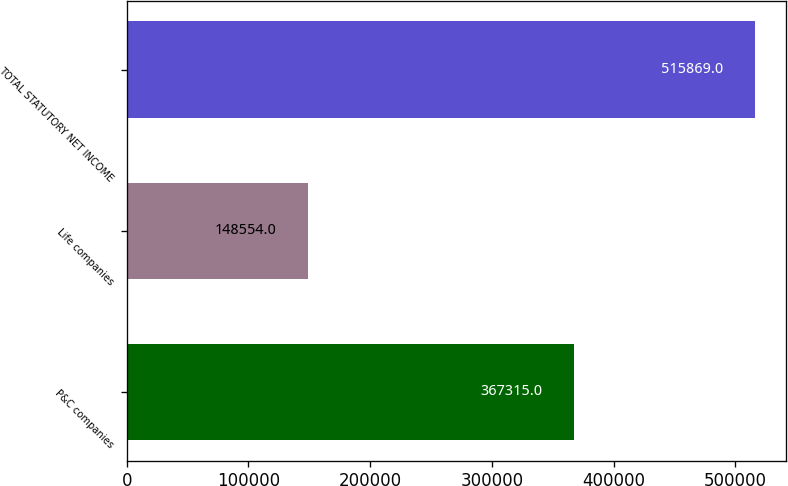<chart> <loc_0><loc_0><loc_500><loc_500><bar_chart><fcel>P&C companies<fcel>Life companies<fcel>TOTAL STATUTORY NET INCOME<nl><fcel>367315<fcel>148554<fcel>515869<nl></chart> 